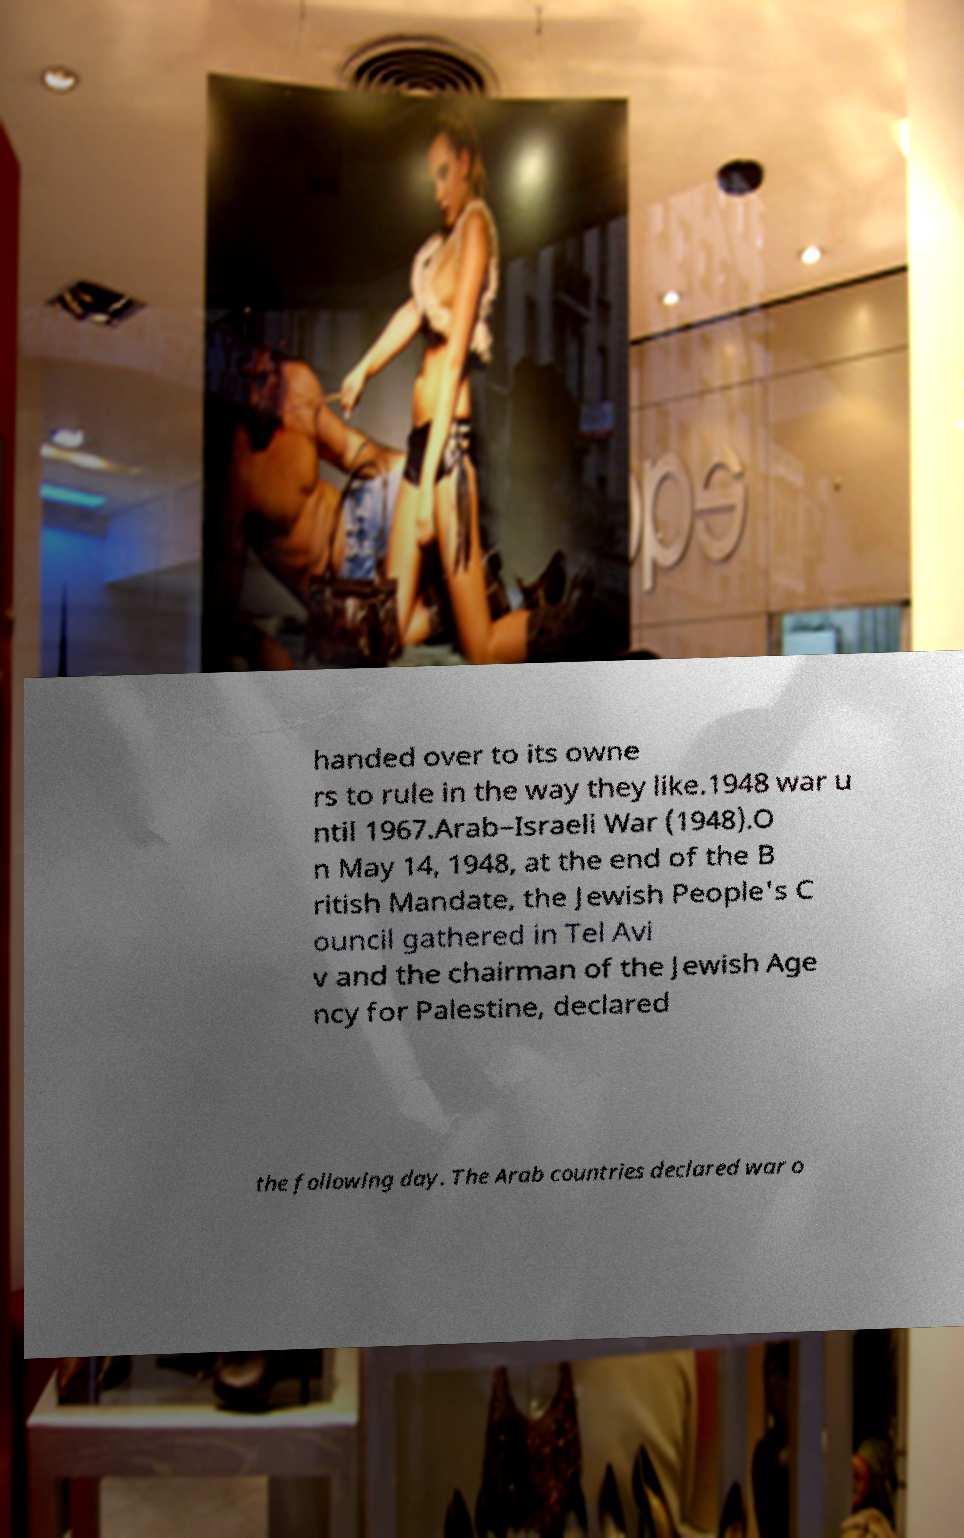For documentation purposes, I need the text within this image transcribed. Could you provide that? handed over to its owne rs to rule in the way they like.1948 war u ntil 1967.Arab–Israeli War (1948).O n May 14, 1948, at the end of the B ritish Mandate, the Jewish People's C ouncil gathered in Tel Avi v and the chairman of the Jewish Age ncy for Palestine, declared the following day. The Arab countries declared war o 